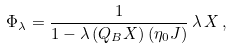<formula> <loc_0><loc_0><loc_500><loc_500>\Phi _ { \lambda } = \frac { 1 } { 1 - \lambda \, ( Q _ { B } X ) \, ( \eta _ { 0 } J ) } \, \lambda \, X \, ,</formula> 